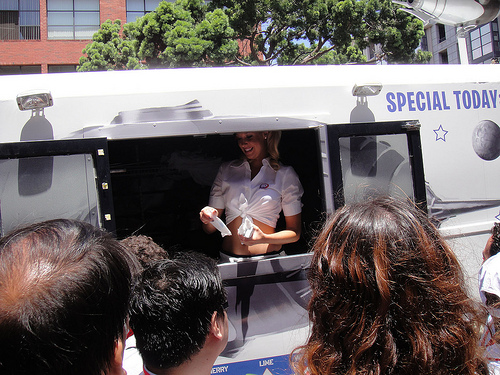<image>
Is there a john behind the sue? No. The john is not behind the sue. From this viewpoint, the john appears to be positioned elsewhere in the scene. Where is the truck in relation to the man? Is it in the man? No. The truck is not contained within the man. These objects have a different spatial relationship. 